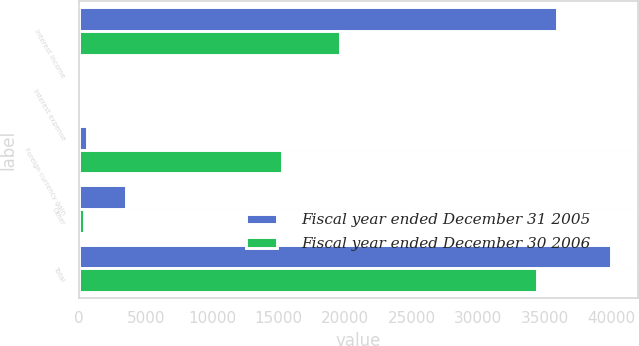Convert chart to OTSL. <chart><loc_0><loc_0><loc_500><loc_500><stacked_bar_chart><ecel><fcel>Interest income<fcel>Interest expense<fcel>Foreign currency gain<fcel>Other<fcel>Total<nl><fcel>Fiscal year ended December 31 2005<fcel>35897<fcel>41<fcel>596<fcel>3543<fcel>39995<nl><fcel>Fiscal year ended December 30 2006<fcel>19586<fcel>48<fcel>15265<fcel>373<fcel>34430<nl></chart> 